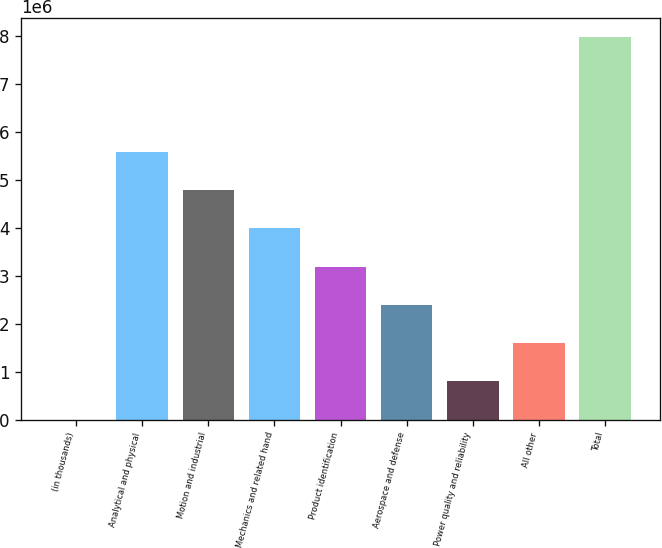Convert chart to OTSL. <chart><loc_0><loc_0><loc_500><loc_500><bar_chart><fcel>(in thousands)<fcel>Analytical and physical<fcel>Motion and industrial<fcel>Mechanics and related hand<fcel>Product identification<fcel>Aerospace and defense<fcel>Power quality and reliability<fcel>All other<fcel>Total<nl><fcel>2005<fcel>5.58989e+06<fcel>4.79162e+06<fcel>3.99335e+06<fcel>3.19508e+06<fcel>2.39681e+06<fcel>800275<fcel>1.59854e+06<fcel>7.9847e+06<nl></chart> 